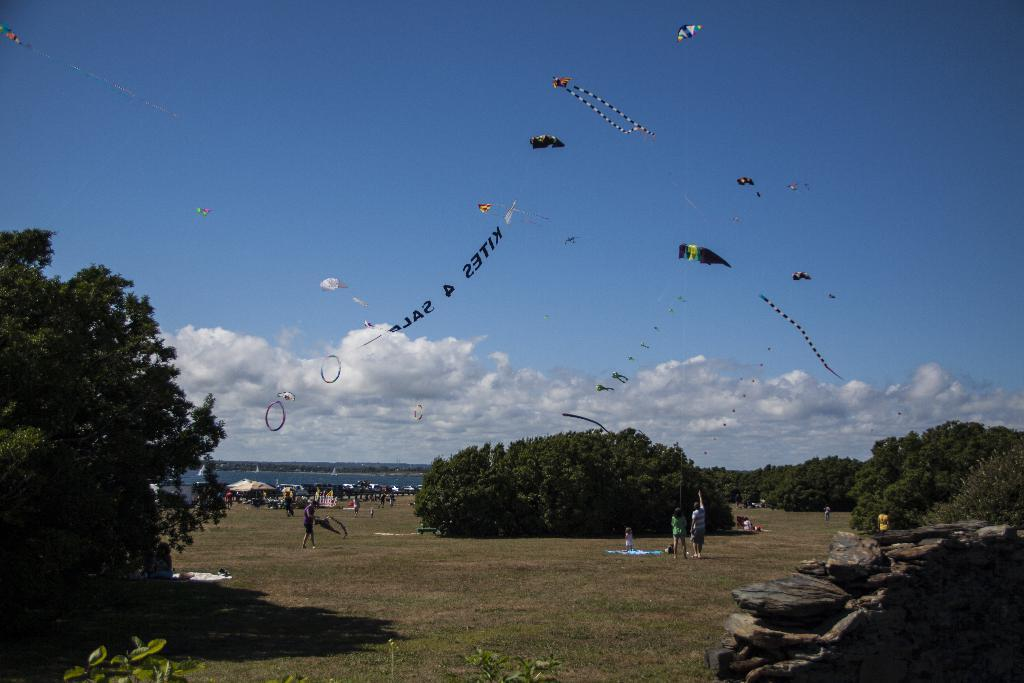Where was the image taken? The image was clicked outside. What can be seen at the top of the image? There is sky visible at the top of the image. What is located in the middle of the image? There are trees in the middle of the image. What are the people in the image doing? The people are flying kites. What type of insurance policy do the trees in the image provide? The trees in the image do not provide any insurance policy; they are simply trees in the background. 